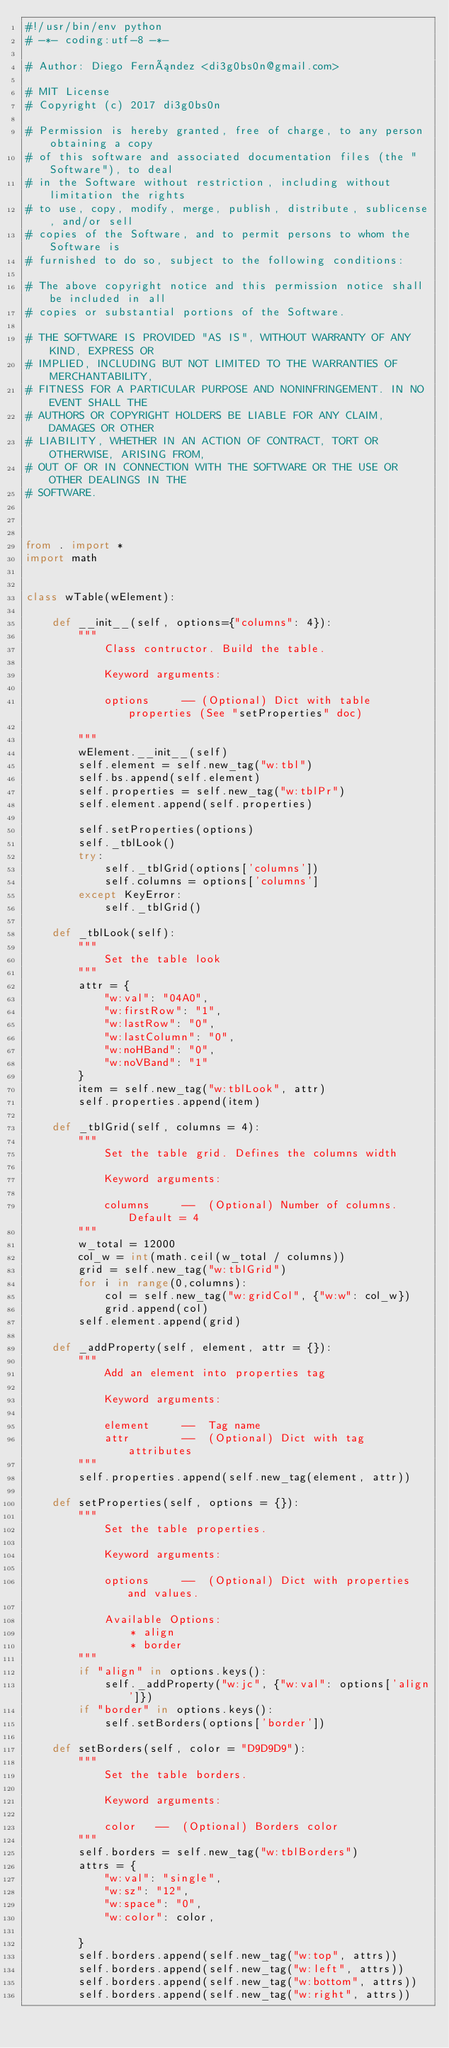<code> <loc_0><loc_0><loc_500><loc_500><_Python_>#!/usr/bin/env python
# -*- coding:utf-8 -*-

# Author: Diego Fernández <di3g0bs0n@gmail.com>

# MIT License
# Copyright (c) 2017 di3g0bs0n

# Permission is hereby granted, free of charge, to any person obtaining a copy
# of this software and associated documentation files (the "Software"), to deal
# in the Software without restriction, including without limitation the rights
# to use, copy, modify, merge, publish, distribute, sublicense, and/or sell
# copies of the Software, and to permit persons to whom the Software is
# furnished to do so, subject to the following conditions:

# The above copyright notice and this permission notice shall be included in all
# copies or substantial portions of the Software.

# THE SOFTWARE IS PROVIDED "AS IS", WITHOUT WARRANTY OF ANY KIND, EXPRESS OR
# IMPLIED, INCLUDING BUT NOT LIMITED TO THE WARRANTIES OF MERCHANTABILITY,
# FITNESS FOR A PARTICULAR PURPOSE AND NONINFRINGEMENT. IN NO EVENT SHALL THE
# AUTHORS OR COPYRIGHT HOLDERS BE LIABLE FOR ANY CLAIM, DAMAGES OR OTHER
# LIABILITY, WHETHER IN AN ACTION OF CONTRACT, TORT OR OTHERWISE, ARISING FROM,
# OUT OF OR IN CONNECTION WITH THE SOFTWARE OR THE USE OR OTHER DEALINGS IN THE
# SOFTWARE.



from . import *
import math


class wTable(wElement):

	def __init__(self, options={"columns": 4}):
		"""
			Class contructor. Build the table. 

			Keyword arguments:

			options 	-- (Optional) Dict with table properties (See "setProperties" doc)

		"""
		wElement.__init__(self)
		self.element = self.new_tag("w:tbl")
		self.bs.append(self.element)
		self.properties = self.new_tag("w:tblPr")
		self.element.append(self.properties)

		self.setProperties(options)
		self._tblLook()
		try:
			self._tblGrid(options['columns'])
			self.columns = options['columns']
		except KeyError:
			self._tblGrid()

	def _tblLook(self):
		"""
			Set the table look
		"""
		attr = {
			"w:val": "04A0",
			"w:firstRow": "1",
			"w:lastRow": "0",
			"w:lastColumn": "0",
			"w:noHBand": "0",
			"w:noVBand": "1"
		}
		item = self.new_tag("w:tblLook", attr)
		self.properties.append(item)

	def _tblGrid(self, columns = 4):
		"""
			Set the table grid. Defines the columns width

			Keyword arguments:

			columns 	--	(Optional) Number of columns. Default = 4
		"""
		w_total = 12000
		col_w = int(math.ceil(w_total / columns))
		grid = self.new_tag("w:tblGrid")
		for i in range(0,columns):
			col = self.new_tag("w:gridCol", {"w:w": col_w})
			grid.append(col)
		self.element.append(grid)

	def _addProperty(self, element, attr = {}):
		"""
			Add an element into properties tag

			Keyword arguments:

			element 	-- 	Tag name
			attr 		--	(Optional) Dict with tag attributes
		"""
		self.properties.append(self.new_tag(element, attr))

	def setProperties(self, options = {}):
		"""
			Set the table properties.

			Keyword arguments:

			options 	--	(Optional) Dict with properties and values.

			Available Options:
				* align
				* border
		"""
		if "align" in options.keys():
			self._addProperty("w:jc", {"w:val": options['align']})
		if "border" in options.keys():
			self.setBorders(options['border'])

	def setBorders(self, color = "D9D9D9"):
		"""
			Set the table borders.

			Keyword arguments:

			color 	--	(Optional) Borders color
		"""
		self.borders = self.new_tag("w:tblBorders")
		attrs = {
			"w:val": "single",
			"w:sz": "12",
			"w:space": "0",
			"w:color": color,

		}
		self.borders.append(self.new_tag("w:top", attrs))
		self.borders.append(self.new_tag("w:left", attrs))
		self.borders.append(self.new_tag("w:bottom", attrs))
		self.borders.append(self.new_tag("w:right", attrs))</code> 